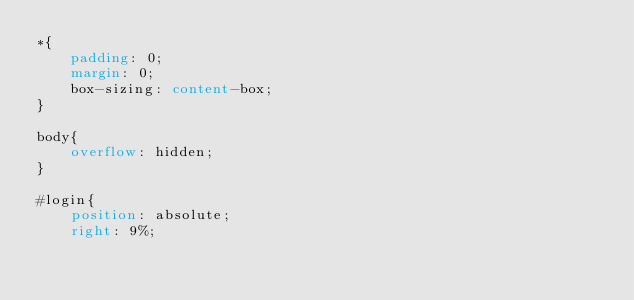<code> <loc_0><loc_0><loc_500><loc_500><_CSS_>*{
    padding: 0;
    margin: 0;
    box-sizing: content-box;
}

body{
    overflow: hidden;
}

#login{
    position: absolute;
    right: 9%;</code> 